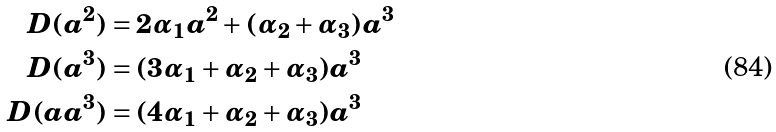Convert formula to latex. <formula><loc_0><loc_0><loc_500><loc_500>D ( a ^ { 2 } ) & = 2 \alpha _ { 1 } a ^ { 2 } + ( \alpha _ { 2 } + \alpha _ { 3 } ) a ^ { 3 } \\ D ( a ^ { 3 } ) & = ( 3 \alpha _ { 1 } + \alpha _ { 2 } + \alpha _ { 3 } ) a ^ { 3 } \\ D ( a a ^ { 3 } ) & = ( 4 \alpha _ { 1 } + \alpha _ { 2 } + \alpha _ { 3 } ) a ^ { 3 }</formula> 